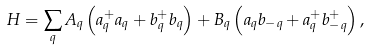<formula> <loc_0><loc_0><loc_500><loc_500>H = \sum _ { q } A _ { q } \left ( a _ { q } ^ { + } a _ { q } + b _ { q } ^ { + } b _ { q } \right ) + B _ { q } \left ( a _ { q } b _ { - { q } } + a _ { q } ^ { + } b _ { - { q } } ^ { + } \right ) ,</formula> 